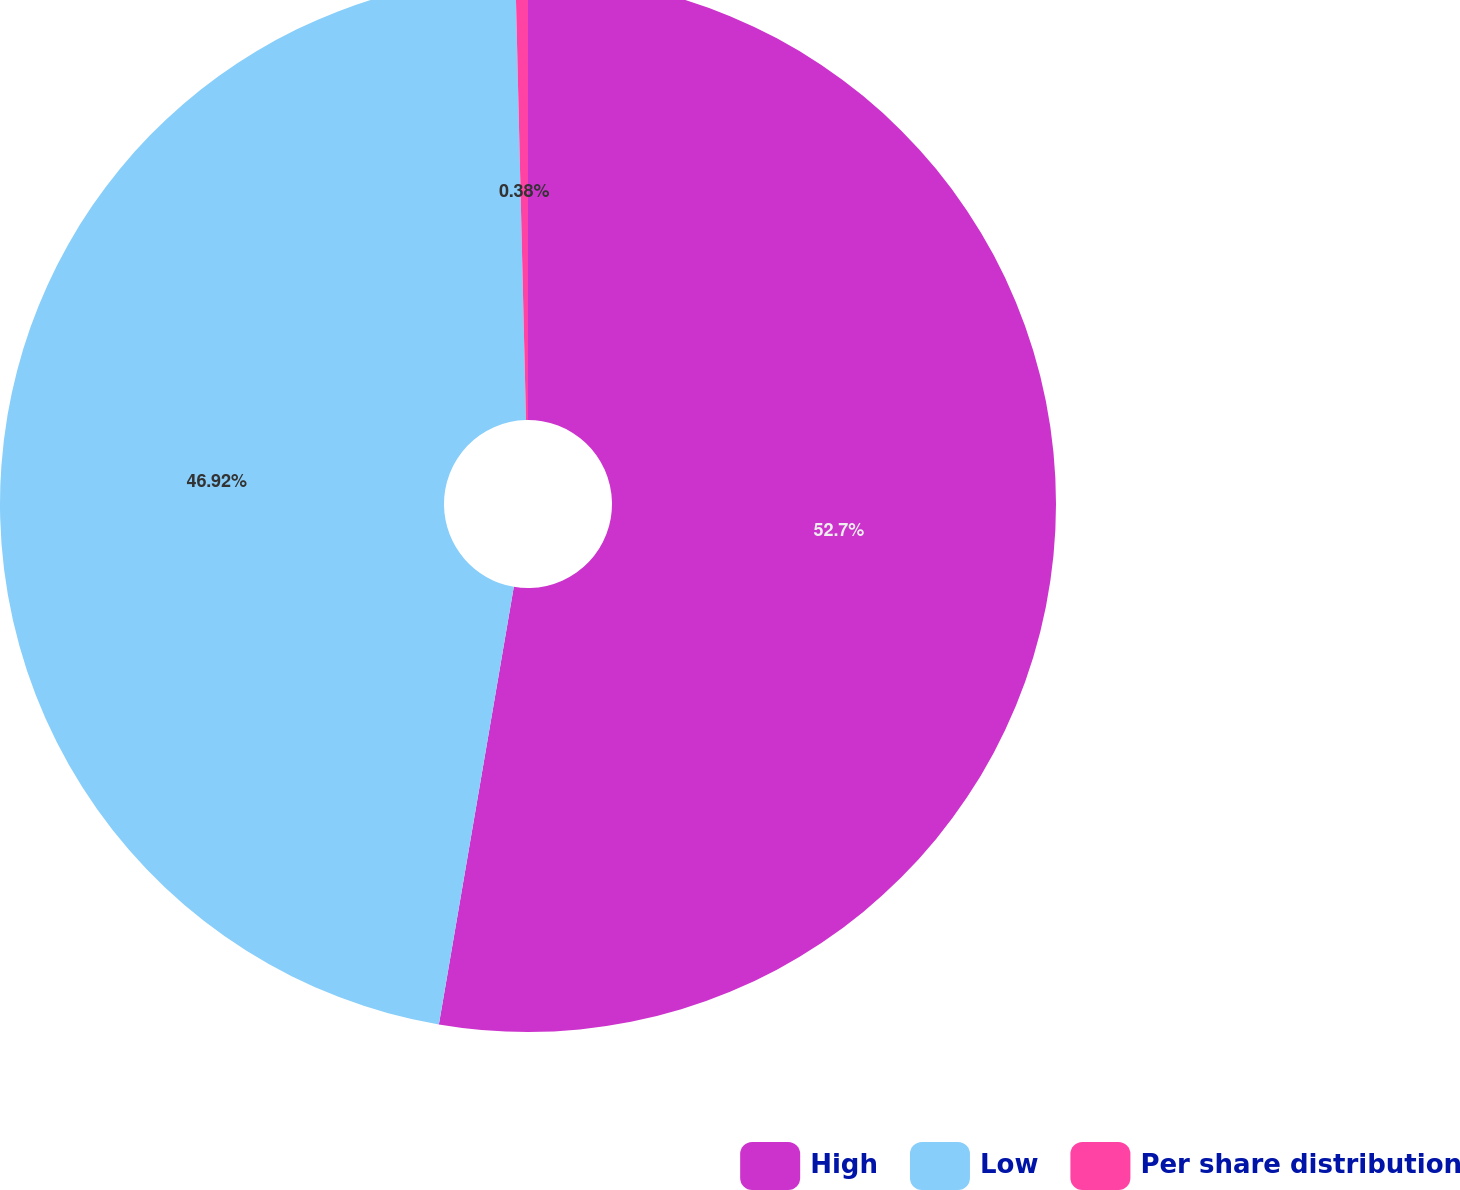Convert chart. <chart><loc_0><loc_0><loc_500><loc_500><pie_chart><fcel>High<fcel>Low<fcel>Per share distribution<nl><fcel>52.7%<fcel>46.92%<fcel>0.38%<nl></chart> 